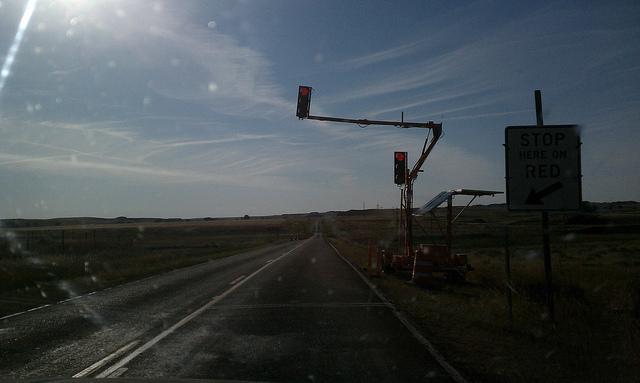Are there planes in the sky?
Answer briefly. No. How many vehicles are visible?
Short answer required. 0. What traffic light is on?
Answer briefly. Red. How many street lights are there?
Concise answer only. 2. 